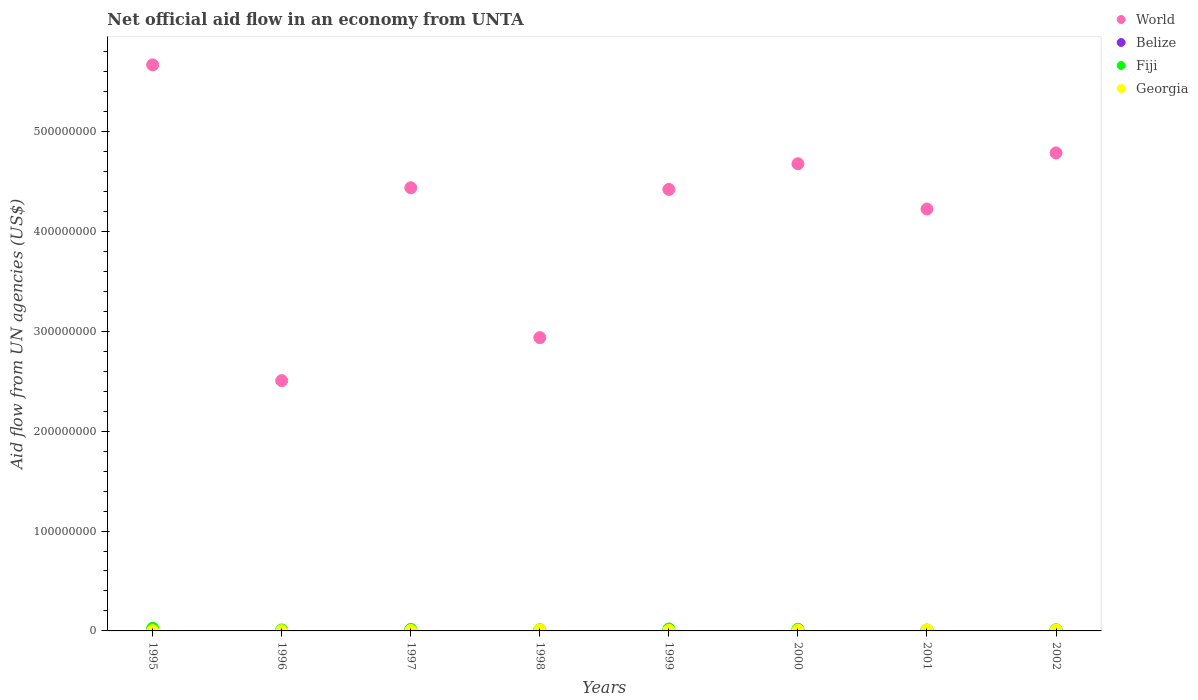Is the number of dotlines equal to the number of legend labels?
Keep it short and to the point. Yes. Across all years, what is the maximum net official aid flow in Belize?
Your answer should be very brief. 7.40e+05. Across all years, what is the minimum net official aid flow in Georgia?
Keep it short and to the point. 2.00e+05. In which year was the net official aid flow in World minimum?
Offer a very short reply. 1996. What is the total net official aid flow in Fiji in the graph?
Give a very brief answer. 1.19e+07. What is the difference between the net official aid flow in Belize in 1999 and that in 2001?
Your response must be concise. -6.00e+04. What is the difference between the net official aid flow in World in 1998 and the net official aid flow in Fiji in 1997?
Your answer should be compact. 2.92e+08. What is the average net official aid flow in World per year?
Your answer should be very brief. 4.21e+08. In the year 1995, what is the difference between the net official aid flow in World and net official aid flow in Belize?
Your response must be concise. 5.66e+08. What is the ratio of the net official aid flow in Fiji in 1995 to that in 1998?
Make the answer very short. 2.17. What is the difference between the highest and the second highest net official aid flow in Fiji?
Keep it short and to the point. 7.00e+05. What is the difference between the highest and the lowest net official aid flow in World?
Offer a very short reply. 3.16e+08. Is it the case that in every year, the sum of the net official aid flow in Fiji and net official aid flow in Belize  is greater than the sum of net official aid flow in Georgia and net official aid flow in World?
Offer a very short reply. Yes. Is it the case that in every year, the sum of the net official aid flow in Fiji and net official aid flow in Georgia  is greater than the net official aid flow in Belize?
Provide a short and direct response. Yes. How many dotlines are there?
Offer a terse response. 4. What is the difference between two consecutive major ticks on the Y-axis?
Make the answer very short. 1.00e+08. Are the values on the major ticks of Y-axis written in scientific E-notation?
Offer a very short reply. No. Does the graph contain grids?
Your answer should be compact. No. How many legend labels are there?
Give a very brief answer. 4. How are the legend labels stacked?
Keep it short and to the point. Vertical. What is the title of the graph?
Give a very brief answer. Net official aid flow in an economy from UNTA. What is the label or title of the Y-axis?
Give a very brief answer. Aid flow from UN agencies (US$). What is the Aid flow from UN agencies (US$) of World in 1995?
Make the answer very short. 5.67e+08. What is the Aid flow from UN agencies (US$) in Belize in 1995?
Offer a terse response. 7.40e+05. What is the Aid flow from UN agencies (US$) of Fiji in 1995?
Provide a short and direct response. 2.60e+06. What is the Aid flow from UN agencies (US$) in World in 1996?
Provide a succinct answer. 2.51e+08. What is the Aid flow from UN agencies (US$) in Fiji in 1996?
Your answer should be very brief. 9.70e+05. What is the Aid flow from UN agencies (US$) in Georgia in 1996?
Provide a short and direct response. 2.00e+05. What is the Aid flow from UN agencies (US$) of World in 1997?
Keep it short and to the point. 4.44e+08. What is the Aid flow from UN agencies (US$) of Fiji in 1997?
Your answer should be very brief. 1.52e+06. What is the Aid flow from UN agencies (US$) of Georgia in 1997?
Your response must be concise. 3.80e+05. What is the Aid flow from UN agencies (US$) of World in 1998?
Your answer should be compact. 2.94e+08. What is the Aid flow from UN agencies (US$) in Fiji in 1998?
Provide a succinct answer. 1.20e+06. What is the Aid flow from UN agencies (US$) in Georgia in 1998?
Your response must be concise. 1.00e+06. What is the Aid flow from UN agencies (US$) of World in 1999?
Give a very brief answer. 4.42e+08. What is the Aid flow from UN agencies (US$) in Belize in 1999?
Provide a short and direct response. 5.80e+05. What is the Aid flow from UN agencies (US$) of Fiji in 1999?
Offer a very short reply. 1.90e+06. What is the Aid flow from UN agencies (US$) of Georgia in 1999?
Provide a short and direct response. 5.70e+05. What is the Aid flow from UN agencies (US$) of World in 2000?
Offer a very short reply. 4.68e+08. What is the Aid flow from UN agencies (US$) of Belize in 2000?
Make the answer very short. 5.70e+05. What is the Aid flow from UN agencies (US$) in Fiji in 2000?
Your response must be concise. 1.65e+06. What is the Aid flow from UN agencies (US$) of Georgia in 2000?
Your response must be concise. 7.80e+05. What is the Aid flow from UN agencies (US$) of World in 2001?
Offer a terse response. 4.22e+08. What is the Aid flow from UN agencies (US$) of Belize in 2001?
Offer a very short reply. 6.40e+05. What is the Aid flow from UN agencies (US$) in Fiji in 2001?
Provide a short and direct response. 9.00e+05. What is the Aid flow from UN agencies (US$) in Georgia in 2001?
Keep it short and to the point. 9.30e+05. What is the Aid flow from UN agencies (US$) of World in 2002?
Make the answer very short. 4.78e+08. What is the Aid flow from UN agencies (US$) in Belize in 2002?
Your answer should be compact. 7.10e+05. What is the Aid flow from UN agencies (US$) of Fiji in 2002?
Provide a succinct answer. 1.16e+06. What is the Aid flow from UN agencies (US$) of Georgia in 2002?
Make the answer very short. 9.00e+05. Across all years, what is the maximum Aid flow from UN agencies (US$) of World?
Provide a succinct answer. 5.67e+08. Across all years, what is the maximum Aid flow from UN agencies (US$) in Belize?
Provide a succinct answer. 7.40e+05. Across all years, what is the maximum Aid flow from UN agencies (US$) in Fiji?
Offer a very short reply. 2.60e+06. Across all years, what is the maximum Aid flow from UN agencies (US$) in Georgia?
Provide a short and direct response. 1.00e+06. Across all years, what is the minimum Aid flow from UN agencies (US$) of World?
Offer a terse response. 2.51e+08. Across all years, what is the minimum Aid flow from UN agencies (US$) in Belize?
Provide a short and direct response. 3.10e+05. Across all years, what is the minimum Aid flow from UN agencies (US$) in Fiji?
Provide a short and direct response. 9.00e+05. Across all years, what is the minimum Aid flow from UN agencies (US$) of Georgia?
Provide a short and direct response. 2.00e+05. What is the total Aid flow from UN agencies (US$) in World in the graph?
Offer a terse response. 3.36e+09. What is the total Aid flow from UN agencies (US$) of Belize in the graph?
Offer a terse response. 4.40e+06. What is the total Aid flow from UN agencies (US$) of Fiji in the graph?
Offer a very short reply. 1.19e+07. What is the total Aid flow from UN agencies (US$) in Georgia in the graph?
Provide a succinct answer. 5.03e+06. What is the difference between the Aid flow from UN agencies (US$) of World in 1995 and that in 1996?
Offer a terse response. 3.16e+08. What is the difference between the Aid flow from UN agencies (US$) of Belize in 1995 and that in 1996?
Offer a terse response. 4.30e+05. What is the difference between the Aid flow from UN agencies (US$) in Fiji in 1995 and that in 1996?
Keep it short and to the point. 1.63e+06. What is the difference between the Aid flow from UN agencies (US$) of Georgia in 1995 and that in 1996?
Provide a succinct answer. 7.00e+04. What is the difference between the Aid flow from UN agencies (US$) of World in 1995 and that in 1997?
Keep it short and to the point. 1.23e+08. What is the difference between the Aid flow from UN agencies (US$) of Belize in 1995 and that in 1997?
Ensure brevity in your answer.  3.10e+05. What is the difference between the Aid flow from UN agencies (US$) of Fiji in 1995 and that in 1997?
Make the answer very short. 1.08e+06. What is the difference between the Aid flow from UN agencies (US$) of Georgia in 1995 and that in 1997?
Your answer should be very brief. -1.10e+05. What is the difference between the Aid flow from UN agencies (US$) of World in 1995 and that in 1998?
Give a very brief answer. 2.73e+08. What is the difference between the Aid flow from UN agencies (US$) of Fiji in 1995 and that in 1998?
Your response must be concise. 1.40e+06. What is the difference between the Aid flow from UN agencies (US$) in Georgia in 1995 and that in 1998?
Give a very brief answer. -7.30e+05. What is the difference between the Aid flow from UN agencies (US$) of World in 1995 and that in 1999?
Give a very brief answer. 1.25e+08. What is the difference between the Aid flow from UN agencies (US$) in World in 1995 and that in 2000?
Ensure brevity in your answer.  9.90e+07. What is the difference between the Aid flow from UN agencies (US$) of Fiji in 1995 and that in 2000?
Your answer should be compact. 9.50e+05. What is the difference between the Aid flow from UN agencies (US$) of Georgia in 1995 and that in 2000?
Make the answer very short. -5.10e+05. What is the difference between the Aid flow from UN agencies (US$) of World in 1995 and that in 2001?
Keep it short and to the point. 1.44e+08. What is the difference between the Aid flow from UN agencies (US$) in Belize in 1995 and that in 2001?
Keep it short and to the point. 1.00e+05. What is the difference between the Aid flow from UN agencies (US$) of Fiji in 1995 and that in 2001?
Offer a terse response. 1.70e+06. What is the difference between the Aid flow from UN agencies (US$) of Georgia in 1995 and that in 2001?
Your response must be concise. -6.60e+05. What is the difference between the Aid flow from UN agencies (US$) of World in 1995 and that in 2002?
Your response must be concise. 8.81e+07. What is the difference between the Aid flow from UN agencies (US$) of Belize in 1995 and that in 2002?
Keep it short and to the point. 3.00e+04. What is the difference between the Aid flow from UN agencies (US$) in Fiji in 1995 and that in 2002?
Offer a very short reply. 1.44e+06. What is the difference between the Aid flow from UN agencies (US$) in Georgia in 1995 and that in 2002?
Offer a terse response. -6.30e+05. What is the difference between the Aid flow from UN agencies (US$) of World in 1996 and that in 1997?
Your answer should be compact. -1.93e+08. What is the difference between the Aid flow from UN agencies (US$) in Fiji in 1996 and that in 1997?
Your response must be concise. -5.50e+05. What is the difference between the Aid flow from UN agencies (US$) of Georgia in 1996 and that in 1997?
Offer a terse response. -1.80e+05. What is the difference between the Aid flow from UN agencies (US$) in World in 1996 and that in 1998?
Ensure brevity in your answer.  -4.31e+07. What is the difference between the Aid flow from UN agencies (US$) in Fiji in 1996 and that in 1998?
Your answer should be very brief. -2.30e+05. What is the difference between the Aid flow from UN agencies (US$) in Georgia in 1996 and that in 1998?
Ensure brevity in your answer.  -8.00e+05. What is the difference between the Aid flow from UN agencies (US$) of World in 1996 and that in 1999?
Offer a terse response. -1.91e+08. What is the difference between the Aid flow from UN agencies (US$) in Fiji in 1996 and that in 1999?
Your answer should be very brief. -9.30e+05. What is the difference between the Aid flow from UN agencies (US$) of Georgia in 1996 and that in 1999?
Make the answer very short. -3.70e+05. What is the difference between the Aid flow from UN agencies (US$) in World in 1996 and that in 2000?
Offer a terse response. -2.17e+08. What is the difference between the Aid flow from UN agencies (US$) of Belize in 1996 and that in 2000?
Your answer should be very brief. -2.60e+05. What is the difference between the Aid flow from UN agencies (US$) in Fiji in 1996 and that in 2000?
Make the answer very short. -6.80e+05. What is the difference between the Aid flow from UN agencies (US$) of Georgia in 1996 and that in 2000?
Your answer should be very brief. -5.80e+05. What is the difference between the Aid flow from UN agencies (US$) of World in 1996 and that in 2001?
Your answer should be compact. -1.72e+08. What is the difference between the Aid flow from UN agencies (US$) in Belize in 1996 and that in 2001?
Provide a succinct answer. -3.30e+05. What is the difference between the Aid flow from UN agencies (US$) in Georgia in 1996 and that in 2001?
Provide a short and direct response. -7.30e+05. What is the difference between the Aid flow from UN agencies (US$) in World in 1996 and that in 2002?
Make the answer very short. -2.28e+08. What is the difference between the Aid flow from UN agencies (US$) in Belize in 1996 and that in 2002?
Give a very brief answer. -4.00e+05. What is the difference between the Aid flow from UN agencies (US$) in Georgia in 1996 and that in 2002?
Provide a short and direct response. -7.00e+05. What is the difference between the Aid flow from UN agencies (US$) in World in 1997 and that in 1998?
Offer a terse response. 1.50e+08. What is the difference between the Aid flow from UN agencies (US$) in Belize in 1997 and that in 1998?
Make the answer very short. 10000. What is the difference between the Aid flow from UN agencies (US$) of Fiji in 1997 and that in 1998?
Ensure brevity in your answer.  3.20e+05. What is the difference between the Aid flow from UN agencies (US$) of Georgia in 1997 and that in 1998?
Provide a succinct answer. -6.20e+05. What is the difference between the Aid flow from UN agencies (US$) of World in 1997 and that in 1999?
Your answer should be very brief. 1.68e+06. What is the difference between the Aid flow from UN agencies (US$) in Belize in 1997 and that in 1999?
Your answer should be very brief. -1.50e+05. What is the difference between the Aid flow from UN agencies (US$) of Fiji in 1997 and that in 1999?
Provide a short and direct response. -3.80e+05. What is the difference between the Aid flow from UN agencies (US$) of Georgia in 1997 and that in 1999?
Provide a short and direct response. -1.90e+05. What is the difference between the Aid flow from UN agencies (US$) in World in 1997 and that in 2000?
Keep it short and to the point. -2.40e+07. What is the difference between the Aid flow from UN agencies (US$) in Fiji in 1997 and that in 2000?
Offer a very short reply. -1.30e+05. What is the difference between the Aid flow from UN agencies (US$) in Georgia in 1997 and that in 2000?
Your answer should be very brief. -4.00e+05. What is the difference between the Aid flow from UN agencies (US$) in World in 1997 and that in 2001?
Your answer should be very brief. 2.13e+07. What is the difference between the Aid flow from UN agencies (US$) of Fiji in 1997 and that in 2001?
Make the answer very short. 6.20e+05. What is the difference between the Aid flow from UN agencies (US$) in Georgia in 1997 and that in 2001?
Give a very brief answer. -5.50e+05. What is the difference between the Aid flow from UN agencies (US$) of World in 1997 and that in 2002?
Make the answer very short. -3.49e+07. What is the difference between the Aid flow from UN agencies (US$) of Belize in 1997 and that in 2002?
Make the answer very short. -2.80e+05. What is the difference between the Aid flow from UN agencies (US$) of Georgia in 1997 and that in 2002?
Provide a succinct answer. -5.20e+05. What is the difference between the Aid flow from UN agencies (US$) of World in 1998 and that in 1999?
Your response must be concise. -1.48e+08. What is the difference between the Aid flow from UN agencies (US$) of Fiji in 1998 and that in 1999?
Provide a short and direct response. -7.00e+05. What is the difference between the Aid flow from UN agencies (US$) of Georgia in 1998 and that in 1999?
Your answer should be very brief. 4.30e+05. What is the difference between the Aid flow from UN agencies (US$) of World in 1998 and that in 2000?
Provide a short and direct response. -1.74e+08. What is the difference between the Aid flow from UN agencies (US$) of Belize in 1998 and that in 2000?
Your answer should be very brief. -1.50e+05. What is the difference between the Aid flow from UN agencies (US$) of Fiji in 1998 and that in 2000?
Offer a terse response. -4.50e+05. What is the difference between the Aid flow from UN agencies (US$) in World in 1998 and that in 2001?
Offer a very short reply. -1.29e+08. What is the difference between the Aid flow from UN agencies (US$) in Fiji in 1998 and that in 2001?
Make the answer very short. 3.00e+05. What is the difference between the Aid flow from UN agencies (US$) in Georgia in 1998 and that in 2001?
Provide a succinct answer. 7.00e+04. What is the difference between the Aid flow from UN agencies (US$) of World in 1998 and that in 2002?
Your answer should be compact. -1.85e+08. What is the difference between the Aid flow from UN agencies (US$) of Belize in 1998 and that in 2002?
Your answer should be compact. -2.90e+05. What is the difference between the Aid flow from UN agencies (US$) of Georgia in 1998 and that in 2002?
Offer a very short reply. 1.00e+05. What is the difference between the Aid flow from UN agencies (US$) of World in 1999 and that in 2000?
Give a very brief answer. -2.57e+07. What is the difference between the Aid flow from UN agencies (US$) in Belize in 1999 and that in 2000?
Your answer should be very brief. 10000. What is the difference between the Aid flow from UN agencies (US$) of Fiji in 1999 and that in 2000?
Make the answer very short. 2.50e+05. What is the difference between the Aid flow from UN agencies (US$) of World in 1999 and that in 2001?
Make the answer very short. 1.96e+07. What is the difference between the Aid flow from UN agencies (US$) of Belize in 1999 and that in 2001?
Provide a short and direct response. -6.00e+04. What is the difference between the Aid flow from UN agencies (US$) of Georgia in 1999 and that in 2001?
Provide a short and direct response. -3.60e+05. What is the difference between the Aid flow from UN agencies (US$) in World in 1999 and that in 2002?
Keep it short and to the point. -3.65e+07. What is the difference between the Aid flow from UN agencies (US$) in Belize in 1999 and that in 2002?
Provide a short and direct response. -1.30e+05. What is the difference between the Aid flow from UN agencies (US$) of Fiji in 1999 and that in 2002?
Provide a short and direct response. 7.40e+05. What is the difference between the Aid flow from UN agencies (US$) in Georgia in 1999 and that in 2002?
Ensure brevity in your answer.  -3.30e+05. What is the difference between the Aid flow from UN agencies (US$) in World in 2000 and that in 2001?
Your response must be concise. 4.53e+07. What is the difference between the Aid flow from UN agencies (US$) of Fiji in 2000 and that in 2001?
Offer a very short reply. 7.50e+05. What is the difference between the Aid flow from UN agencies (US$) of Georgia in 2000 and that in 2001?
Keep it short and to the point. -1.50e+05. What is the difference between the Aid flow from UN agencies (US$) in World in 2000 and that in 2002?
Provide a succinct answer. -1.08e+07. What is the difference between the Aid flow from UN agencies (US$) in Fiji in 2000 and that in 2002?
Give a very brief answer. 4.90e+05. What is the difference between the Aid flow from UN agencies (US$) of Georgia in 2000 and that in 2002?
Your answer should be very brief. -1.20e+05. What is the difference between the Aid flow from UN agencies (US$) of World in 2001 and that in 2002?
Ensure brevity in your answer.  -5.62e+07. What is the difference between the Aid flow from UN agencies (US$) of Belize in 2001 and that in 2002?
Give a very brief answer. -7.00e+04. What is the difference between the Aid flow from UN agencies (US$) of Georgia in 2001 and that in 2002?
Offer a terse response. 3.00e+04. What is the difference between the Aid flow from UN agencies (US$) in World in 1995 and the Aid flow from UN agencies (US$) in Belize in 1996?
Your answer should be compact. 5.66e+08. What is the difference between the Aid flow from UN agencies (US$) in World in 1995 and the Aid flow from UN agencies (US$) in Fiji in 1996?
Your answer should be very brief. 5.66e+08. What is the difference between the Aid flow from UN agencies (US$) of World in 1995 and the Aid flow from UN agencies (US$) of Georgia in 1996?
Your response must be concise. 5.66e+08. What is the difference between the Aid flow from UN agencies (US$) in Belize in 1995 and the Aid flow from UN agencies (US$) in Fiji in 1996?
Your answer should be compact. -2.30e+05. What is the difference between the Aid flow from UN agencies (US$) in Belize in 1995 and the Aid flow from UN agencies (US$) in Georgia in 1996?
Keep it short and to the point. 5.40e+05. What is the difference between the Aid flow from UN agencies (US$) in Fiji in 1995 and the Aid flow from UN agencies (US$) in Georgia in 1996?
Offer a very short reply. 2.40e+06. What is the difference between the Aid flow from UN agencies (US$) in World in 1995 and the Aid flow from UN agencies (US$) in Belize in 1997?
Make the answer very short. 5.66e+08. What is the difference between the Aid flow from UN agencies (US$) in World in 1995 and the Aid flow from UN agencies (US$) in Fiji in 1997?
Provide a short and direct response. 5.65e+08. What is the difference between the Aid flow from UN agencies (US$) in World in 1995 and the Aid flow from UN agencies (US$) in Georgia in 1997?
Offer a terse response. 5.66e+08. What is the difference between the Aid flow from UN agencies (US$) of Belize in 1995 and the Aid flow from UN agencies (US$) of Fiji in 1997?
Provide a short and direct response. -7.80e+05. What is the difference between the Aid flow from UN agencies (US$) of Fiji in 1995 and the Aid flow from UN agencies (US$) of Georgia in 1997?
Your response must be concise. 2.22e+06. What is the difference between the Aid flow from UN agencies (US$) in World in 1995 and the Aid flow from UN agencies (US$) in Belize in 1998?
Offer a very short reply. 5.66e+08. What is the difference between the Aid flow from UN agencies (US$) in World in 1995 and the Aid flow from UN agencies (US$) in Fiji in 1998?
Provide a succinct answer. 5.65e+08. What is the difference between the Aid flow from UN agencies (US$) in World in 1995 and the Aid flow from UN agencies (US$) in Georgia in 1998?
Provide a short and direct response. 5.66e+08. What is the difference between the Aid flow from UN agencies (US$) of Belize in 1995 and the Aid flow from UN agencies (US$) of Fiji in 1998?
Your answer should be compact. -4.60e+05. What is the difference between the Aid flow from UN agencies (US$) in Fiji in 1995 and the Aid flow from UN agencies (US$) in Georgia in 1998?
Offer a very short reply. 1.60e+06. What is the difference between the Aid flow from UN agencies (US$) in World in 1995 and the Aid flow from UN agencies (US$) in Belize in 1999?
Your response must be concise. 5.66e+08. What is the difference between the Aid flow from UN agencies (US$) in World in 1995 and the Aid flow from UN agencies (US$) in Fiji in 1999?
Offer a terse response. 5.65e+08. What is the difference between the Aid flow from UN agencies (US$) in World in 1995 and the Aid flow from UN agencies (US$) in Georgia in 1999?
Ensure brevity in your answer.  5.66e+08. What is the difference between the Aid flow from UN agencies (US$) in Belize in 1995 and the Aid flow from UN agencies (US$) in Fiji in 1999?
Offer a terse response. -1.16e+06. What is the difference between the Aid flow from UN agencies (US$) in Fiji in 1995 and the Aid flow from UN agencies (US$) in Georgia in 1999?
Your answer should be compact. 2.03e+06. What is the difference between the Aid flow from UN agencies (US$) in World in 1995 and the Aid flow from UN agencies (US$) in Belize in 2000?
Your answer should be compact. 5.66e+08. What is the difference between the Aid flow from UN agencies (US$) of World in 1995 and the Aid flow from UN agencies (US$) of Fiji in 2000?
Give a very brief answer. 5.65e+08. What is the difference between the Aid flow from UN agencies (US$) of World in 1995 and the Aid flow from UN agencies (US$) of Georgia in 2000?
Provide a short and direct response. 5.66e+08. What is the difference between the Aid flow from UN agencies (US$) in Belize in 1995 and the Aid flow from UN agencies (US$) in Fiji in 2000?
Keep it short and to the point. -9.10e+05. What is the difference between the Aid flow from UN agencies (US$) in Belize in 1995 and the Aid flow from UN agencies (US$) in Georgia in 2000?
Ensure brevity in your answer.  -4.00e+04. What is the difference between the Aid flow from UN agencies (US$) in Fiji in 1995 and the Aid flow from UN agencies (US$) in Georgia in 2000?
Provide a succinct answer. 1.82e+06. What is the difference between the Aid flow from UN agencies (US$) in World in 1995 and the Aid flow from UN agencies (US$) in Belize in 2001?
Ensure brevity in your answer.  5.66e+08. What is the difference between the Aid flow from UN agencies (US$) in World in 1995 and the Aid flow from UN agencies (US$) in Fiji in 2001?
Keep it short and to the point. 5.66e+08. What is the difference between the Aid flow from UN agencies (US$) of World in 1995 and the Aid flow from UN agencies (US$) of Georgia in 2001?
Provide a short and direct response. 5.66e+08. What is the difference between the Aid flow from UN agencies (US$) of Belize in 1995 and the Aid flow from UN agencies (US$) of Fiji in 2001?
Your response must be concise. -1.60e+05. What is the difference between the Aid flow from UN agencies (US$) in Fiji in 1995 and the Aid flow from UN agencies (US$) in Georgia in 2001?
Your answer should be very brief. 1.67e+06. What is the difference between the Aid flow from UN agencies (US$) in World in 1995 and the Aid flow from UN agencies (US$) in Belize in 2002?
Keep it short and to the point. 5.66e+08. What is the difference between the Aid flow from UN agencies (US$) of World in 1995 and the Aid flow from UN agencies (US$) of Fiji in 2002?
Keep it short and to the point. 5.65e+08. What is the difference between the Aid flow from UN agencies (US$) in World in 1995 and the Aid flow from UN agencies (US$) in Georgia in 2002?
Your answer should be compact. 5.66e+08. What is the difference between the Aid flow from UN agencies (US$) of Belize in 1995 and the Aid flow from UN agencies (US$) of Fiji in 2002?
Ensure brevity in your answer.  -4.20e+05. What is the difference between the Aid flow from UN agencies (US$) in Belize in 1995 and the Aid flow from UN agencies (US$) in Georgia in 2002?
Your answer should be very brief. -1.60e+05. What is the difference between the Aid flow from UN agencies (US$) of Fiji in 1995 and the Aid flow from UN agencies (US$) of Georgia in 2002?
Your answer should be compact. 1.70e+06. What is the difference between the Aid flow from UN agencies (US$) of World in 1996 and the Aid flow from UN agencies (US$) of Belize in 1997?
Your answer should be very brief. 2.50e+08. What is the difference between the Aid flow from UN agencies (US$) in World in 1996 and the Aid flow from UN agencies (US$) in Fiji in 1997?
Make the answer very short. 2.49e+08. What is the difference between the Aid flow from UN agencies (US$) of World in 1996 and the Aid flow from UN agencies (US$) of Georgia in 1997?
Keep it short and to the point. 2.50e+08. What is the difference between the Aid flow from UN agencies (US$) of Belize in 1996 and the Aid flow from UN agencies (US$) of Fiji in 1997?
Your answer should be very brief. -1.21e+06. What is the difference between the Aid flow from UN agencies (US$) of Fiji in 1996 and the Aid flow from UN agencies (US$) of Georgia in 1997?
Give a very brief answer. 5.90e+05. What is the difference between the Aid flow from UN agencies (US$) of World in 1996 and the Aid flow from UN agencies (US$) of Belize in 1998?
Your response must be concise. 2.50e+08. What is the difference between the Aid flow from UN agencies (US$) of World in 1996 and the Aid flow from UN agencies (US$) of Fiji in 1998?
Your answer should be very brief. 2.49e+08. What is the difference between the Aid flow from UN agencies (US$) in World in 1996 and the Aid flow from UN agencies (US$) in Georgia in 1998?
Keep it short and to the point. 2.50e+08. What is the difference between the Aid flow from UN agencies (US$) in Belize in 1996 and the Aid flow from UN agencies (US$) in Fiji in 1998?
Give a very brief answer. -8.90e+05. What is the difference between the Aid flow from UN agencies (US$) in Belize in 1996 and the Aid flow from UN agencies (US$) in Georgia in 1998?
Offer a terse response. -6.90e+05. What is the difference between the Aid flow from UN agencies (US$) in Fiji in 1996 and the Aid flow from UN agencies (US$) in Georgia in 1998?
Provide a succinct answer. -3.00e+04. What is the difference between the Aid flow from UN agencies (US$) in World in 1996 and the Aid flow from UN agencies (US$) in Belize in 1999?
Your response must be concise. 2.50e+08. What is the difference between the Aid flow from UN agencies (US$) in World in 1996 and the Aid flow from UN agencies (US$) in Fiji in 1999?
Your answer should be very brief. 2.49e+08. What is the difference between the Aid flow from UN agencies (US$) in World in 1996 and the Aid flow from UN agencies (US$) in Georgia in 1999?
Your response must be concise. 2.50e+08. What is the difference between the Aid flow from UN agencies (US$) in Belize in 1996 and the Aid flow from UN agencies (US$) in Fiji in 1999?
Offer a terse response. -1.59e+06. What is the difference between the Aid flow from UN agencies (US$) in World in 1996 and the Aid flow from UN agencies (US$) in Belize in 2000?
Make the answer very short. 2.50e+08. What is the difference between the Aid flow from UN agencies (US$) of World in 1996 and the Aid flow from UN agencies (US$) of Fiji in 2000?
Your response must be concise. 2.49e+08. What is the difference between the Aid flow from UN agencies (US$) of World in 1996 and the Aid flow from UN agencies (US$) of Georgia in 2000?
Give a very brief answer. 2.50e+08. What is the difference between the Aid flow from UN agencies (US$) in Belize in 1996 and the Aid flow from UN agencies (US$) in Fiji in 2000?
Ensure brevity in your answer.  -1.34e+06. What is the difference between the Aid flow from UN agencies (US$) of Belize in 1996 and the Aid flow from UN agencies (US$) of Georgia in 2000?
Provide a short and direct response. -4.70e+05. What is the difference between the Aid flow from UN agencies (US$) of Fiji in 1996 and the Aid flow from UN agencies (US$) of Georgia in 2000?
Your answer should be very brief. 1.90e+05. What is the difference between the Aid flow from UN agencies (US$) of World in 1996 and the Aid flow from UN agencies (US$) of Belize in 2001?
Provide a short and direct response. 2.50e+08. What is the difference between the Aid flow from UN agencies (US$) of World in 1996 and the Aid flow from UN agencies (US$) of Fiji in 2001?
Provide a short and direct response. 2.50e+08. What is the difference between the Aid flow from UN agencies (US$) of World in 1996 and the Aid flow from UN agencies (US$) of Georgia in 2001?
Offer a very short reply. 2.50e+08. What is the difference between the Aid flow from UN agencies (US$) of Belize in 1996 and the Aid flow from UN agencies (US$) of Fiji in 2001?
Your answer should be compact. -5.90e+05. What is the difference between the Aid flow from UN agencies (US$) in Belize in 1996 and the Aid flow from UN agencies (US$) in Georgia in 2001?
Your response must be concise. -6.20e+05. What is the difference between the Aid flow from UN agencies (US$) in World in 1996 and the Aid flow from UN agencies (US$) in Belize in 2002?
Offer a terse response. 2.50e+08. What is the difference between the Aid flow from UN agencies (US$) of World in 1996 and the Aid flow from UN agencies (US$) of Fiji in 2002?
Your answer should be very brief. 2.49e+08. What is the difference between the Aid flow from UN agencies (US$) in World in 1996 and the Aid flow from UN agencies (US$) in Georgia in 2002?
Offer a terse response. 2.50e+08. What is the difference between the Aid flow from UN agencies (US$) of Belize in 1996 and the Aid flow from UN agencies (US$) of Fiji in 2002?
Your answer should be very brief. -8.50e+05. What is the difference between the Aid flow from UN agencies (US$) in Belize in 1996 and the Aid flow from UN agencies (US$) in Georgia in 2002?
Make the answer very short. -5.90e+05. What is the difference between the Aid flow from UN agencies (US$) in Fiji in 1996 and the Aid flow from UN agencies (US$) in Georgia in 2002?
Offer a terse response. 7.00e+04. What is the difference between the Aid flow from UN agencies (US$) of World in 1997 and the Aid flow from UN agencies (US$) of Belize in 1998?
Provide a short and direct response. 4.43e+08. What is the difference between the Aid flow from UN agencies (US$) of World in 1997 and the Aid flow from UN agencies (US$) of Fiji in 1998?
Give a very brief answer. 4.42e+08. What is the difference between the Aid flow from UN agencies (US$) of World in 1997 and the Aid flow from UN agencies (US$) of Georgia in 1998?
Ensure brevity in your answer.  4.43e+08. What is the difference between the Aid flow from UN agencies (US$) in Belize in 1997 and the Aid flow from UN agencies (US$) in Fiji in 1998?
Ensure brevity in your answer.  -7.70e+05. What is the difference between the Aid flow from UN agencies (US$) of Belize in 1997 and the Aid flow from UN agencies (US$) of Georgia in 1998?
Your response must be concise. -5.70e+05. What is the difference between the Aid flow from UN agencies (US$) of Fiji in 1997 and the Aid flow from UN agencies (US$) of Georgia in 1998?
Offer a terse response. 5.20e+05. What is the difference between the Aid flow from UN agencies (US$) in World in 1997 and the Aid flow from UN agencies (US$) in Belize in 1999?
Your answer should be very brief. 4.43e+08. What is the difference between the Aid flow from UN agencies (US$) in World in 1997 and the Aid flow from UN agencies (US$) in Fiji in 1999?
Your response must be concise. 4.42e+08. What is the difference between the Aid flow from UN agencies (US$) of World in 1997 and the Aid flow from UN agencies (US$) of Georgia in 1999?
Provide a short and direct response. 4.43e+08. What is the difference between the Aid flow from UN agencies (US$) in Belize in 1997 and the Aid flow from UN agencies (US$) in Fiji in 1999?
Provide a short and direct response. -1.47e+06. What is the difference between the Aid flow from UN agencies (US$) of Fiji in 1997 and the Aid flow from UN agencies (US$) of Georgia in 1999?
Make the answer very short. 9.50e+05. What is the difference between the Aid flow from UN agencies (US$) in World in 1997 and the Aid flow from UN agencies (US$) in Belize in 2000?
Give a very brief answer. 4.43e+08. What is the difference between the Aid flow from UN agencies (US$) of World in 1997 and the Aid flow from UN agencies (US$) of Fiji in 2000?
Offer a terse response. 4.42e+08. What is the difference between the Aid flow from UN agencies (US$) in World in 1997 and the Aid flow from UN agencies (US$) in Georgia in 2000?
Offer a terse response. 4.43e+08. What is the difference between the Aid flow from UN agencies (US$) of Belize in 1997 and the Aid flow from UN agencies (US$) of Fiji in 2000?
Provide a short and direct response. -1.22e+06. What is the difference between the Aid flow from UN agencies (US$) in Belize in 1997 and the Aid flow from UN agencies (US$) in Georgia in 2000?
Your answer should be compact. -3.50e+05. What is the difference between the Aid flow from UN agencies (US$) of Fiji in 1997 and the Aid flow from UN agencies (US$) of Georgia in 2000?
Your answer should be very brief. 7.40e+05. What is the difference between the Aid flow from UN agencies (US$) in World in 1997 and the Aid flow from UN agencies (US$) in Belize in 2001?
Offer a terse response. 4.43e+08. What is the difference between the Aid flow from UN agencies (US$) in World in 1997 and the Aid flow from UN agencies (US$) in Fiji in 2001?
Make the answer very short. 4.43e+08. What is the difference between the Aid flow from UN agencies (US$) in World in 1997 and the Aid flow from UN agencies (US$) in Georgia in 2001?
Ensure brevity in your answer.  4.43e+08. What is the difference between the Aid flow from UN agencies (US$) of Belize in 1997 and the Aid flow from UN agencies (US$) of Fiji in 2001?
Give a very brief answer. -4.70e+05. What is the difference between the Aid flow from UN agencies (US$) of Belize in 1997 and the Aid flow from UN agencies (US$) of Georgia in 2001?
Provide a succinct answer. -5.00e+05. What is the difference between the Aid flow from UN agencies (US$) in Fiji in 1997 and the Aid flow from UN agencies (US$) in Georgia in 2001?
Offer a very short reply. 5.90e+05. What is the difference between the Aid flow from UN agencies (US$) in World in 1997 and the Aid flow from UN agencies (US$) in Belize in 2002?
Your answer should be very brief. 4.43e+08. What is the difference between the Aid flow from UN agencies (US$) in World in 1997 and the Aid flow from UN agencies (US$) in Fiji in 2002?
Your response must be concise. 4.42e+08. What is the difference between the Aid flow from UN agencies (US$) of World in 1997 and the Aid flow from UN agencies (US$) of Georgia in 2002?
Provide a succinct answer. 4.43e+08. What is the difference between the Aid flow from UN agencies (US$) in Belize in 1997 and the Aid flow from UN agencies (US$) in Fiji in 2002?
Give a very brief answer. -7.30e+05. What is the difference between the Aid flow from UN agencies (US$) in Belize in 1997 and the Aid flow from UN agencies (US$) in Georgia in 2002?
Ensure brevity in your answer.  -4.70e+05. What is the difference between the Aid flow from UN agencies (US$) of Fiji in 1997 and the Aid flow from UN agencies (US$) of Georgia in 2002?
Make the answer very short. 6.20e+05. What is the difference between the Aid flow from UN agencies (US$) in World in 1998 and the Aid flow from UN agencies (US$) in Belize in 1999?
Make the answer very short. 2.93e+08. What is the difference between the Aid flow from UN agencies (US$) in World in 1998 and the Aid flow from UN agencies (US$) in Fiji in 1999?
Provide a succinct answer. 2.92e+08. What is the difference between the Aid flow from UN agencies (US$) in World in 1998 and the Aid flow from UN agencies (US$) in Georgia in 1999?
Offer a very short reply. 2.93e+08. What is the difference between the Aid flow from UN agencies (US$) of Belize in 1998 and the Aid flow from UN agencies (US$) of Fiji in 1999?
Offer a very short reply. -1.48e+06. What is the difference between the Aid flow from UN agencies (US$) in Fiji in 1998 and the Aid flow from UN agencies (US$) in Georgia in 1999?
Offer a terse response. 6.30e+05. What is the difference between the Aid flow from UN agencies (US$) in World in 1998 and the Aid flow from UN agencies (US$) in Belize in 2000?
Provide a short and direct response. 2.93e+08. What is the difference between the Aid flow from UN agencies (US$) in World in 1998 and the Aid flow from UN agencies (US$) in Fiji in 2000?
Give a very brief answer. 2.92e+08. What is the difference between the Aid flow from UN agencies (US$) in World in 1998 and the Aid flow from UN agencies (US$) in Georgia in 2000?
Provide a short and direct response. 2.93e+08. What is the difference between the Aid flow from UN agencies (US$) in Belize in 1998 and the Aid flow from UN agencies (US$) in Fiji in 2000?
Provide a succinct answer. -1.23e+06. What is the difference between the Aid flow from UN agencies (US$) in Belize in 1998 and the Aid flow from UN agencies (US$) in Georgia in 2000?
Your answer should be very brief. -3.60e+05. What is the difference between the Aid flow from UN agencies (US$) of World in 1998 and the Aid flow from UN agencies (US$) of Belize in 2001?
Make the answer very short. 2.93e+08. What is the difference between the Aid flow from UN agencies (US$) in World in 1998 and the Aid flow from UN agencies (US$) in Fiji in 2001?
Keep it short and to the point. 2.93e+08. What is the difference between the Aid flow from UN agencies (US$) in World in 1998 and the Aid flow from UN agencies (US$) in Georgia in 2001?
Offer a terse response. 2.93e+08. What is the difference between the Aid flow from UN agencies (US$) of Belize in 1998 and the Aid flow from UN agencies (US$) of Fiji in 2001?
Give a very brief answer. -4.80e+05. What is the difference between the Aid flow from UN agencies (US$) of Belize in 1998 and the Aid flow from UN agencies (US$) of Georgia in 2001?
Your answer should be very brief. -5.10e+05. What is the difference between the Aid flow from UN agencies (US$) in World in 1998 and the Aid flow from UN agencies (US$) in Belize in 2002?
Your answer should be compact. 2.93e+08. What is the difference between the Aid flow from UN agencies (US$) of World in 1998 and the Aid flow from UN agencies (US$) of Fiji in 2002?
Provide a succinct answer. 2.92e+08. What is the difference between the Aid flow from UN agencies (US$) of World in 1998 and the Aid flow from UN agencies (US$) of Georgia in 2002?
Ensure brevity in your answer.  2.93e+08. What is the difference between the Aid flow from UN agencies (US$) in Belize in 1998 and the Aid flow from UN agencies (US$) in Fiji in 2002?
Provide a succinct answer. -7.40e+05. What is the difference between the Aid flow from UN agencies (US$) of Belize in 1998 and the Aid flow from UN agencies (US$) of Georgia in 2002?
Your answer should be very brief. -4.80e+05. What is the difference between the Aid flow from UN agencies (US$) of Fiji in 1998 and the Aid flow from UN agencies (US$) of Georgia in 2002?
Your response must be concise. 3.00e+05. What is the difference between the Aid flow from UN agencies (US$) in World in 1999 and the Aid flow from UN agencies (US$) in Belize in 2000?
Offer a terse response. 4.41e+08. What is the difference between the Aid flow from UN agencies (US$) in World in 1999 and the Aid flow from UN agencies (US$) in Fiji in 2000?
Offer a very short reply. 4.40e+08. What is the difference between the Aid flow from UN agencies (US$) in World in 1999 and the Aid flow from UN agencies (US$) in Georgia in 2000?
Offer a terse response. 4.41e+08. What is the difference between the Aid flow from UN agencies (US$) in Belize in 1999 and the Aid flow from UN agencies (US$) in Fiji in 2000?
Provide a short and direct response. -1.07e+06. What is the difference between the Aid flow from UN agencies (US$) of Fiji in 1999 and the Aid flow from UN agencies (US$) of Georgia in 2000?
Your answer should be very brief. 1.12e+06. What is the difference between the Aid flow from UN agencies (US$) of World in 1999 and the Aid flow from UN agencies (US$) of Belize in 2001?
Offer a very short reply. 4.41e+08. What is the difference between the Aid flow from UN agencies (US$) of World in 1999 and the Aid flow from UN agencies (US$) of Fiji in 2001?
Offer a terse response. 4.41e+08. What is the difference between the Aid flow from UN agencies (US$) of World in 1999 and the Aid flow from UN agencies (US$) of Georgia in 2001?
Your response must be concise. 4.41e+08. What is the difference between the Aid flow from UN agencies (US$) of Belize in 1999 and the Aid flow from UN agencies (US$) of Fiji in 2001?
Your response must be concise. -3.20e+05. What is the difference between the Aid flow from UN agencies (US$) in Belize in 1999 and the Aid flow from UN agencies (US$) in Georgia in 2001?
Offer a very short reply. -3.50e+05. What is the difference between the Aid flow from UN agencies (US$) in Fiji in 1999 and the Aid flow from UN agencies (US$) in Georgia in 2001?
Keep it short and to the point. 9.70e+05. What is the difference between the Aid flow from UN agencies (US$) in World in 1999 and the Aid flow from UN agencies (US$) in Belize in 2002?
Keep it short and to the point. 4.41e+08. What is the difference between the Aid flow from UN agencies (US$) in World in 1999 and the Aid flow from UN agencies (US$) in Fiji in 2002?
Your answer should be compact. 4.41e+08. What is the difference between the Aid flow from UN agencies (US$) in World in 1999 and the Aid flow from UN agencies (US$) in Georgia in 2002?
Your answer should be very brief. 4.41e+08. What is the difference between the Aid flow from UN agencies (US$) of Belize in 1999 and the Aid flow from UN agencies (US$) of Fiji in 2002?
Offer a terse response. -5.80e+05. What is the difference between the Aid flow from UN agencies (US$) of Belize in 1999 and the Aid flow from UN agencies (US$) of Georgia in 2002?
Ensure brevity in your answer.  -3.20e+05. What is the difference between the Aid flow from UN agencies (US$) of Fiji in 1999 and the Aid flow from UN agencies (US$) of Georgia in 2002?
Provide a succinct answer. 1.00e+06. What is the difference between the Aid flow from UN agencies (US$) of World in 2000 and the Aid flow from UN agencies (US$) of Belize in 2001?
Offer a terse response. 4.67e+08. What is the difference between the Aid flow from UN agencies (US$) in World in 2000 and the Aid flow from UN agencies (US$) in Fiji in 2001?
Make the answer very short. 4.67e+08. What is the difference between the Aid flow from UN agencies (US$) of World in 2000 and the Aid flow from UN agencies (US$) of Georgia in 2001?
Keep it short and to the point. 4.67e+08. What is the difference between the Aid flow from UN agencies (US$) of Belize in 2000 and the Aid flow from UN agencies (US$) of Fiji in 2001?
Make the answer very short. -3.30e+05. What is the difference between the Aid flow from UN agencies (US$) in Belize in 2000 and the Aid flow from UN agencies (US$) in Georgia in 2001?
Your response must be concise. -3.60e+05. What is the difference between the Aid flow from UN agencies (US$) of Fiji in 2000 and the Aid flow from UN agencies (US$) of Georgia in 2001?
Keep it short and to the point. 7.20e+05. What is the difference between the Aid flow from UN agencies (US$) in World in 2000 and the Aid flow from UN agencies (US$) in Belize in 2002?
Provide a short and direct response. 4.67e+08. What is the difference between the Aid flow from UN agencies (US$) of World in 2000 and the Aid flow from UN agencies (US$) of Fiji in 2002?
Provide a short and direct response. 4.66e+08. What is the difference between the Aid flow from UN agencies (US$) in World in 2000 and the Aid flow from UN agencies (US$) in Georgia in 2002?
Your answer should be very brief. 4.67e+08. What is the difference between the Aid flow from UN agencies (US$) in Belize in 2000 and the Aid flow from UN agencies (US$) in Fiji in 2002?
Keep it short and to the point. -5.90e+05. What is the difference between the Aid flow from UN agencies (US$) of Belize in 2000 and the Aid flow from UN agencies (US$) of Georgia in 2002?
Keep it short and to the point. -3.30e+05. What is the difference between the Aid flow from UN agencies (US$) in Fiji in 2000 and the Aid flow from UN agencies (US$) in Georgia in 2002?
Give a very brief answer. 7.50e+05. What is the difference between the Aid flow from UN agencies (US$) of World in 2001 and the Aid flow from UN agencies (US$) of Belize in 2002?
Your response must be concise. 4.22e+08. What is the difference between the Aid flow from UN agencies (US$) in World in 2001 and the Aid flow from UN agencies (US$) in Fiji in 2002?
Your answer should be very brief. 4.21e+08. What is the difference between the Aid flow from UN agencies (US$) in World in 2001 and the Aid flow from UN agencies (US$) in Georgia in 2002?
Keep it short and to the point. 4.21e+08. What is the difference between the Aid flow from UN agencies (US$) in Belize in 2001 and the Aid flow from UN agencies (US$) in Fiji in 2002?
Provide a succinct answer. -5.20e+05. What is the difference between the Aid flow from UN agencies (US$) in Belize in 2001 and the Aid flow from UN agencies (US$) in Georgia in 2002?
Provide a short and direct response. -2.60e+05. What is the average Aid flow from UN agencies (US$) in World per year?
Your answer should be compact. 4.21e+08. What is the average Aid flow from UN agencies (US$) in Fiji per year?
Offer a very short reply. 1.49e+06. What is the average Aid flow from UN agencies (US$) in Georgia per year?
Your response must be concise. 6.29e+05. In the year 1995, what is the difference between the Aid flow from UN agencies (US$) of World and Aid flow from UN agencies (US$) of Belize?
Make the answer very short. 5.66e+08. In the year 1995, what is the difference between the Aid flow from UN agencies (US$) in World and Aid flow from UN agencies (US$) in Fiji?
Offer a terse response. 5.64e+08. In the year 1995, what is the difference between the Aid flow from UN agencies (US$) in World and Aid flow from UN agencies (US$) in Georgia?
Offer a terse response. 5.66e+08. In the year 1995, what is the difference between the Aid flow from UN agencies (US$) of Belize and Aid flow from UN agencies (US$) of Fiji?
Provide a succinct answer. -1.86e+06. In the year 1995, what is the difference between the Aid flow from UN agencies (US$) of Belize and Aid flow from UN agencies (US$) of Georgia?
Make the answer very short. 4.70e+05. In the year 1995, what is the difference between the Aid flow from UN agencies (US$) in Fiji and Aid flow from UN agencies (US$) in Georgia?
Give a very brief answer. 2.33e+06. In the year 1996, what is the difference between the Aid flow from UN agencies (US$) in World and Aid flow from UN agencies (US$) in Belize?
Offer a very short reply. 2.50e+08. In the year 1996, what is the difference between the Aid flow from UN agencies (US$) of World and Aid flow from UN agencies (US$) of Fiji?
Your answer should be very brief. 2.50e+08. In the year 1996, what is the difference between the Aid flow from UN agencies (US$) in World and Aid flow from UN agencies (US$) in Georgia?
Your response must be concise. 2.50e+08. In the year 1996, what is the difference between the Aid flow from UN agencies (US$) in Belize and Aid flow from UN agencies (US$) in Fiji?
Offer a terse response. -6.60e+05. In the year 1996, what is the difference between the Aid flow from UN agencies (US$) of Belize and Aid flow from UN agencies (US$) of Georgia?
Offer a very short reply. 1.10e+05. In the year 1996, what is the difference between the Aid flow from UN agencies (US$) of Fiji and Aid flow from UN agencies (US$) of Georgia?
Keep it short and to the point. 7.70e+05. In the year 1997, what is the difference between the Aid flow from UN agencies (US$) in World and Aid flow from UN agencies (US$) in Belize?
Your answer should be very brief. 4.43e+08. In the year 1997, what is the difference between the Aid flow from UN agencies (US$) in World and Aid flow from UN agencies (US$) in Fiji?
Give a very brief answer. 4.42e+08. In the year 1997, what is the difference between the Aid flow from UN agencies (US$) of World and Aid flow from UN agencies (US$) of Georgia?
Give a very brief answer. 4.43e+08. In the year 1997, what is the difference between the Aid flow from UN agencies (US$) of Belize and Aid flow from UN agencies (US$) of Fiji?
Provide a short and direct response. -1.09e+06. In the year 1997, what is the difference between the Aid flow from UN agencies (US$) of Fiji and Aid flow from UN agencies (US$) of Georgia?
Offer a very short reply. 1.14e+06. In the year 1998, what is the difference between the Aid flow from UN agencies (US$) of World and Aid flow from UN agencies (US$) of Belize?
Your answer should be compact. 2.93e+08. In the year 1998, what is the difference between the Aid flow from UN agencies (US$) of World and Aid flow from UN agencies (US$) of Fiji?
Offer a very short reply. 2.92e+08. In the year 1998, what is the difference between the Aid flow from UN agencies (US$) in World and Aid flow from UN agencies (US$) in Georgia?
Ensure brevity in your answer.  2.93e+08. In the year 1998, what is the difference between the Aid flow from UN agencies (US$) in Belize and Aid flow from UN agencies (US$) in Fiji?
Offer a terse response. -7.80e+05. In the year 1998, what is the difference between the Aid flow from UN agencies (US$) in Belize and Aid flow from UN agencies (US$) in Georgia?
Ensure brevity in your answer.  -5.80e+05. In the year 1999, what is the difference between the Aid flow from UN agencies (US$) in World and Aid flow from UN agencies (US$) in Belize?
Ensure brevity in your answer.  4.41e+08. In the year 1999, what is the difference between the Aid flow from UN agencies (US$) in World and Aid flow from UN agencies (US$) in Fiji?
Make the answer very short. 4.40e+08. In the year 1999, what is the difference between the Aid flow from UN agencies (US$) in World and Aid flow from UN agencies (US$) in Georgia?
Make the answer very short. 4.41e+08. In the year 1999, what is the difference between the Aid flow from UN agencies (US$) of Belize and Aid flow from UN agencies (US$) of Fiji?
Ensure brevity in your answer.  -1.32e+06. In the year 1999, what is the difference between the Aid flow from UN agencies (US$) of Belize and Aid flow from UN agencies (US$) of Georgia?
Make the answer very short. 10000. In the year 1999, what is the difference between the Aid flow from UN agencies (US$) of Fiji and Aid flow from UN agencies (US$) of Georgia?
Provide a short and direct response. 1.33e+06. In the year 2000, what is the difference between the Aid flow from UN agencies (US$) of World and Aid flow from UN agencies (US$) of Belize?
Make the answer very short. 4.67e+08. In the year 2000, what is the difference between the Aid flow from UN agencies (US$) of World and Aid flow from UN agencies (US$) of Fiji?
Your response must be concise. 4.66e+08. In the year 2000, what is the difference between the Aid flow from UN agencies (US$) in World and Aid flow from UN agencies (US$) in Georgia?
Your answer should be compact. 4.67e+08. In the year 2000, what is the difference between the Aid flow from UN agencies (US$) in Belize and Aid flow from UN agencies (US$) in Fiji?
Provide a short and direct response. -1.08e+06. In the year 2000, what is the difference between the Aid flow from UN agencies (US$) in Belize and Aid flow from UN agencies (US$) in Georgia?
Offer a very short reply. -2.10e+05. In the year 2000, what is the difference between the Aid flow from UN agencies (US$) in Fiji and Aid flow from UN agencies (US$) in Georgia?
Provide a short and direct response. 8.70e+05. In the year 2001, what is the difference between the Aid flow from UN agencies (US$) of World and Aid flow from UN agencies (US$) of Belize?
Keep it short and to the point. 4.22e+08. In the year 2001, what is the difference between the Aid flow from UN agencies (US$) of World and Aid flow from UN agencies (US$) of Fiji?
Your response must be concise. 4.21e+08. In the year 2001, what is the difference between the Aid flow from UN agencies (US$) in World and Aid flow from UN agencies (US$) in Georgia?
Your answer should be compact. 4.21e+08. In the year 2001, what is the difference between the Aid flow from UN agencies (US$) in Belize and Aid flow from UN agencies (US$) in Georgia?
Provide a succinct answer. -2.90e+05. In the year 2001, what is the difference between the Aid flow from UN agencies (US$) of Fiji and Aid flow from UN agencies (US$) of Georgia?
Ensure brevity in your answer.  -3.00e+04. In the year 2002, what is the difference between the Aid flow from UN agencies (US$) in World and Aid flow from UN agencies (US$) in Belize?
Give a very brief answer. 4.78e+08. In the year 2002, what is the difference between the Aid flow from UN agencies (US$) in World and Aid flow from UN agencies (US$) in Fiji?
Offer a very short reply. 4.77e+08. In the year 2002, what is the difference between the Aid flow from UN agencies (US$) in World and Aid flow from UN agencies (US$) in Georgia?
Your answer should be compact. 4.78e+08. In the year 2002, what is the difference between the Aid flow from UN agencies (US$) in Belize and Aid flow from UN agencies (US$) in Fiji?
Provide a short and direct response. -4.50e+05. What is the ratio of the Aid flow from UN agencies (US$) in World in 1995 to that in 1996?
Offer a terse response. 2.26. What is the ratio of the Aid flow from UN agencies (US$) in Belize in 1995 to that in 1996?
Provide a succinct answer. 2.39. What is the ratio of the Aid flow from UN agencies (US$) of Fiji in 1995 to that in 1996?
Make the answer very short. 2.68. What is the ratio of the Aid flow from UN agencies (US$) in Georgia in 1995 to that in 1996?
Your answer should be compact. 1.35. What is the ratio of the Aid flow from UN agencies (US$) of World in 1995 to that in 1997?
Your answer should be very brief. 1.28. What is the ratio of the Aid flow from UN agencies (US$) in Belize in 1995 to that in 1997?
Keep it short and to the point. 1.72. What is the ratio of the Aid flow from UN agencies (US$) of Fiji in 1995 to that in 1997?
Provide a succinct answer. 1.71. What is the ratio of the Aid flow from UN agencies (US$) of Georgia in 1995 to that in 1997?
Your answer should be compact. 0.71. What is the ratio of the Aid flow from UN agencies (US$) of World in 1995 to that in 1998?
Give a very brief answer. 1.93. What is the ratio of the Aid flow from UN agencies (US$) of Belize in 1995 to that in 1998?
Your answer should be compact. 1.76. What is the ratio of the Aid flow from UN agencies (US$) of Fiji in 1995 to that in 1998?
Your answer should be compact. 2.17. What is the ratio of the Aid flow from UN agencies (US$) in Georgia in 1995 to that in 1998?
Offer a very short reply. 0.27. What is the ratio of the Aid flow from UN agencies (US$) of World in 1995 to that in 1999?
Make the answer very short. 1.28. What is the ratio of the Aid flow from UN agencies (US$) in Belize in 1995 to that in 1999?
Ensure brevity in your answer.  1.28. What is the ratio of the Aid flow from UN agencies (US$) in Fiji in 1995 to that in 1999?
Provide a short and direct response. 1.37. What is the ratio of the Aid flow from UN agencies (US$) of Georgia in 1995 to that in 1999?
Your answer should be very brief. 0.47. What is the ratio of the Aid flow from UN agencies (US$) in World in 1995 to that in 2000?
Your response must be concise. 1.21. What is the ratio of the Aid flow from UN agencies (US$) of Belize in 1995 to that in 2000?
Keep it short and to the point. 1.3. What is the ratio of the Aid flow from UN agencies (US$) of Fiji in 1995 to that in 2000?
Give a very brief answer. 1.58. What is the ratio of the Aid flow from UN agencies (US$) of Georgia in 1995 to that in 2000?
Make the answer very short. 0.35. What is the ratio of the Aid flow from UN agencies (US$) in World in 1995 to that in 2001?
Your answer should be compact. 1.34. What is the ratio of the Aid flow from UN agencies (US$) in Belize in 1995 to that in 2001?
Offer a very short reply. 1.16. What is the ratio of the Aid flow from UN agencies (US$) of Fiji in 1995 to that in 2001?
Your response must be concise. 2.89. What is the ratio of the Aid flow from UN agencies (US$) in Georgia in 1995 to that in 2001?
Keep it short and to the point. 0.29. What is the ratio of the Aid flow from UN agencies (US$) of World in 1995 to that in 2002?
Keep it short and to the point. 1.18. What is the ratio of the Aid flow from UN agencies (US$) of Belize in 1995 to that in 2002?
Offer a terse response. 1.04. What is the ratio of the Aid flow from UN agencies (US$) of Fiji in 1995 to that in 2002?
Give a very brief answer. 2.24. What is the ratio of the Aid flow from UN agencies (US$) in World in 1996 to that in 1997?
Keep it short and to the point. 0.56. What is the ratio of the Aid flow from UN agencies (US$) of Belize in 1996 to that in 1997?
Your answer should be compact. 0.72. What is the ratio of the Aid flow from UN agencies (US$) of Fiji in 1996 to that in 1997?
Offer a very short reply. 0.64. What is the ratio of the Aid flow from UN agencies (US$) in Georgia in 1996 to that in 1997?
Your response must be concise. 0.53. What is the ratio of the Aid flow from UN agencies (US$) in World in 1996 to that in 1998?
Offer a very short reply. 0.85. What is the ratio of the Aid flow from UN agencies (US$) in Belize in 1996 to that in 1998?
Ensure brevity in your answer.  0.74. What is the ratio of the Aid flow from UN agencies (US$) in Fiji in 1996 to that in 1998?
Keep it short and to the point. 0.81. What is the ratio of the Aid flow from UN agencies (US$) of Georgia in 1996 to that in 1998?
Your response must be concise. 0.2. What is the ratio of the Aid flow from UN agencies (US$) in World in 1996 to that in 1999?
Offer a very short reply. 0.57. What is the ratio of the Aid flow from UN agencies (US$) of Belize in 1996 to that in 1999?
Give a very brief answer. 0.53. What is the ratio of the Aid flow from UN agencies (US$) in Fiji in 1996 to that in 1999?
Keep it short and to the point. 0.51. What is the ratio of the Aid flow from UN agencies (US$) of Georgia in 1996 to that in 1999?
Offer a very short reply. 0.35. What is the ratio of the Aid flow from UN agencies (US$) of World in 1996 to that in 2000?
Your response must be concise. 0.54. What is the ratio of the Aid flow from UN agencies (US$) of Belize in 1996 to that in 2000?
Make the answer very short. 0.54. What is the ratio of the Aid flow from UN agencies (US$) of Fiji in 1996 to that in 2000?
Your answer should be very brief. 0.59. What is the ratio of the Aid flow from UN agencies (US$) in Georgia in 1996 to that in 2000?
Make the answer very short. 0.26. What is the ratio of the Aid flow from UN agencies (US$) in World in 1996 to that in 2001?
Give a very brief answer. 0.59. What is the ratio of the Aid flow from UN agencies (US$) of Belize in 1996 to that in 2001?
Give a very brief answer. 0.48. What is the ratio of the Aid flow from UN agencies (US$) in Fiji in 1996 to that in 2001?
Your answer should be compact. 1.08. What is the ratio of the Aid flow from UN agencies (US$) in Georgia in 1996 to that in 2001?
Offer a very short reply. 0.22. What is the ratio of the Aid flow from UN agencies (US$) of World in 1996 to that in 2002?
Your answer should be compact. 0.52. What is the ratio of the Aid flow from UN agencies (US$) of Belize in 1996 to that in 2002?
Give a very brief answer. 0.44. What is the ratio of the Aid flow from UN agencies (US$) of Fiji in 1996 to that in 2002?
Make the answer very short. 0.84. What is the ratio of the Aid flow from UN agencies (US$) in Georgia in 1996 to that in 2002?
Provide a succinct answer. 0.22. What is the ratio of the Aid flow from UN agencies (US$) of World in 1997 to that in 1998?
Your answer should be compact. 1.51. What is the ratio of the Aid flow from UN agencies (US$) of Belize in 1997 to that in 1998?
Give a very brief answer. 1.02. What is the ratio of the Aid flow from UN agencies (US$) in Fiji in 1997 to that in 1998?
Give a very brief answer. 1.27. What is the ratio of the Aid flow from UN agencies (US$) of Georgia in 1997 to that in 1998?
Provide a succinct answer. 0.38. What is the ratio of the Aid flow from UN agencies (US$) in World in 1997 to that in 1999?
Provide a succinct answer. 1. What is the ratio of the Aid flow from UN agencies (US$) of Belize in 1997 to that in 1999?
Offer a very short reply. 0.74. What is the ratio of the Aid flow from UN agencies (US$) in World in 1997 to that in 2000?
Offer a very short reply. 0.95. What is the ratio of the Aid flow from UN agencies (US$) of Belize in 1997 to that in 2000?
Offer a terse response. 0.75. What is the ratio of the Aid flow from UN agencies (US$) of Fiji in 1997 to that in 2000?
Make the answer very short. 0.92. What is the ratio of the Aid flow from UN agencies (US$) of Georgia in 1997 to that in 2000?
Your answer should be very brief. 0.49. What is the ratio of the Aid flow from UN agencies (US$) in World in 1997 to that in 2001?
Your answer should be very brief. 1.05. What is the ratio of the Aid flow from UN agencies (US$) in Belize in 1997 to that in 2001?
Make the answer very short. 0.67. What is the ratio of the Aid flow from UN agencies (US$) of Fiji in 1997 to that in 2001?
Make the answer very short. 1.69. What is the ratio of the Aid flow from UN agencies (US$) in Georgia in 1997 to that in 2001?
Your response must be concise. 0.41. What is the ratio of the Aid flow from UN agencies (US$) in World in 1997 to that in 2002?
Make the answer very short. 0.93. What is the ratio of the Aid flow from UN agencies (US$) in Belize in 1997 to that in 2002?
Your answer should be compact. 0.61. What is the ratio of the Aid flow from UN agencies (US$) of Fiji in 1997 to that in 2002?
Your response must be concise. 1.31. What is the ratio of the Aid flow from UN agencies (US$) of Georgia in 1997 to that in 2002?
Offer a terse response. 0.42. What is the ratio of the Aid flow from UN agencies (US$) of World in 1998 to that in 1999?
Give a very brief answer. 0.66. What is the ratio of the Aid flow from UN agencies (US$) of Belize in 1998 to that in 1999?
Make the answer very short. 0.72. What is the ratio of the Aid flow from UN agencies (US$) of Fiji in 1998 to that in 1999?
Make the answer very short. 0.63. What is the ratio of the Aid flow from UN agencies (US$) of Georgia in 1998 to that in 1999?
Offer a very short reply. 1.75. What is the ratio of the Aid flow from UN agencies (US$) of World in 1998 to that in 2000?
Give a very brief answer. 0.63. What is the ratio of the Aid flow from UN agencies (US$) of Belize in 1998 to that in 2000?
Your answer should be compact. 0.74. What is the ratio of the Aid flow from UN agencies (US$) of Fiji in 1998 to that in 2000?
Offer a terse response. 0.73. What is the ratio of the Aid flow from UN agencies (US$) of Georgia in 1998 to that in 2000?
Ensure brevity in your answer.  1.28. What is the ratio of the Aid flow from UN agencies (US$) of World in 1998 to that in 2001?
Make the answer very short. 0.7. What is the ratio of the Aid flow from UN agencies (US$) in Belize in 1998 to that in 2001?
Your answer should be very brief. 0.66. What is the ratio of the Aid flow from UN agencies (US$) of Fiji in 1998 to that in 2001?
Your answer should be compact. 1.33. What is the ratio of the Aid flow from UN agencies (US$) of Georgia in 1998 to that in 2001?
Make the answer very short. 1.08. What is the ratio of the Aid flow from UN agencies (US$) of World in 1998 to that in 2002?
Offer a very short reply. 0.61. What is the ratio of the Aid flow from UN agencies (US$) in Belize in 1998 to that in 2002?
Offer a very short reply. 0.59. What is the ratio of the Aid flow from UN agencies (US$) of Fiji in 1998 to that in 2002?
Your answer should be compact. 1.03. What is the ratio of the Aid flow from UN agencies (US$) in World in 1999 to that in 2000?
Provide a succinct answer. 0.94. What is the ratio of the Aid flow from UN agencies (US$) in Belize in 1999 to that in 2000?
Offer a terse response. 1.02. What is the ratio of the Aid flow from UN agencies (US$) of Fiji in 1999 to that in 2000?
Offer a terse response. 1.15. What is the ratio of the Aid flow from UN agencies (US$) of Georgia in 1999 to that in 2000?
Offer a terse response. 0.73. What is the ratio of the Aid flow from UN agencies (US$) in World in 1999 to that in 2001?
Provide a short and direct response. 1.05. What is the ratio of the Aid flow from UN agencies (US$) in Belize in 1999 to that in 2001?
Give a very brief answer. 0.91. What is the ratio of the Aid flow from UN agencies (US$) in Fiji in 1999 to that in 2001?
Offer a terse response. 2.11. What is the ratio of the Aid flow from UN agencies (US$) of Georgia in 1999 to that in 2001?
Make the answer very short. 0.61. What is the ratio of the Aid flow from UN agencies (US$) of World in 1999 to that in 2002?
Offer a very short reply. 0.92. What is the ratio of the Aid flow from UN agencies (US$) in Belize in 1999 to that in 2002?
Provide a succinct answer. 0.82. What is the ratio of the Aid flow from UN agencies (US$) in Fiji in 1999 to that in 2002?
Your answer should be very brief. 1.64. What is the ratio of the Aid flow from UN agencies (US$) of Georgia in 1999 to that in 2002?
Provide a succinct answer. 0.63. What is the ratio of the Aid flow from UN agencies (US$) of World in 2000 to that in 2001?
Make the answer very short. 1.11. What is the ratio of the Aid flow from UN agencies (US$) of Belize in 2000 to that in 2001?
Make the answer very short. 0.89. What is the ratio of the Aid flow from UN agencies (US$) in Fiji in 2000 to that in 2001?
Ensure brevity in your answer.  1.83. What is the ratio of the Aid flow from UN agencies (US$) in Georgia in 2000 to that in 2001?
Provide a succinct answer. 0.84. What is the ratio of the Aid flow from UN agencies (US$) of World in 2000 to that in 2002?
Provide a short and direct response. 0.98. What is the ratio of the Aid flow from UN agencies (US$) in Belize in 2000 to that in 2002?
Make the answer very short. 0.8. What is the ratio of the Aid flow from UN agencies (US$) in Fiji in 2000 to that in 2002?
Ensure brevity in your answer.  1.42. What is the ratio of the Aid flow from UN agencies (US$) of Georgia in 2000 to that in 2002?
Your answer should be very brief. 0.87. What is the ratio of the Aid flow from UN agencies (US$) in World in 2001 to that in 2002?
Your answer should be compact. 0.88. What is the ratio of the Aid flow from UN agencies (US$) in Belize in 2001 to that in 2002?
Provide a succinct answer. 0.9. What is the ratio of the Aid flow from UN agencies (US$) of Fiji in 2001 to that in 2002?
Keep it short and to the point. 0.78. What is the difference between the highest and the second highest Aid flow from UN agencies (US$) in World?
Ensure brevity in your answer.  8.81e+07. What is the difference between the highest and the second highest Aid flow from UN agencies (US$) in Belize?
Make the answer very short. 3.00e+04. What is the difference between the highest and the second highest Aid flow from UN agencies (US$) in Fiji?
Offer a very short reply. 7.00e+05. What is the difference between the highest and the second highest Aid flow from UN agencies (US$) in Georgia?
Offer a very short reply. 7.00e+04. What is the difference between the highest and the lowest Aid flow from UN agencies (US$) of World?
Your answer should be very brief. 3.16e+08. What is the difference between the highest and the lowest Aid flow from UN agencies (US$) of Belize?
Offer a very short reply. 4.30e+05. What is the difference between the highest and the lowest Aid flow from UN agencies (US$) in Fiji?
Make the answer very short. 1.70e+06. What is the difference between the highest and the lowest Aid flow from UN agencies (US$) in Georgia?
Provide a short and direct response. 8.00e+05. 